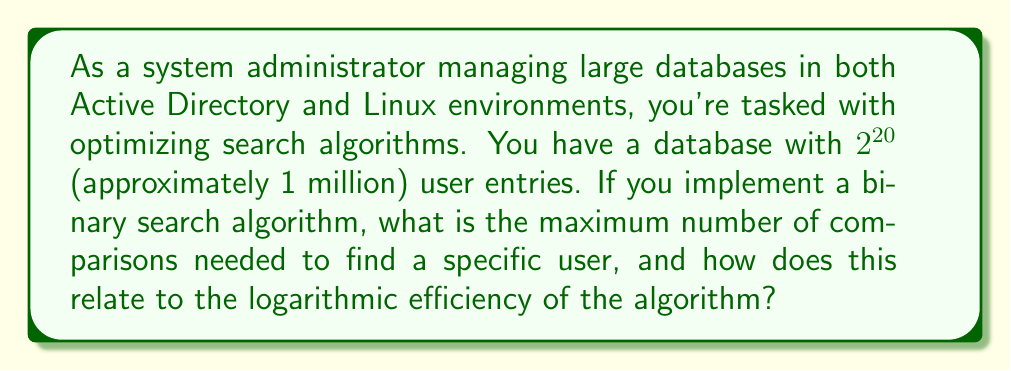Teach me how to tackle this problem. To solve this problem, we need to understand the efficiency of binary search algorithms and how they relate to logarithms.

1) Binary search works by repeatedly dividing the search interval in half. The maximum number of comparisons needed is related to how many times we can divide the total number of entries by 2 until we reach 1.

2) This is precisely what the logarithm base 2 represents. The formula for the maximum number of comparisons in a binary search is:

   $$\lfloor \log_2(n) \rfloor + 1$$

   Where $n$ is the number of entries, and $\lfloor \rfloor$ represents the floor function.

3) In this case, $n = 2^{20}$

4) Applying the formula:

   $$\lfloor \log_2(2^{20}) \rfloor + 1$$

5) Using the logarithm property $\log_a(a^x) = x$:

   $$\lfloor 20 \rfloor + 1 = 20 + 1 = 21$$

6) This logarithmic efficiency demonstrates why binary search is so powerful for large datasets. While the database size is about 1 million entries, we only need a maximum of 21 comparisons.

7) To put this in perspective, a linear search would require up to 1 million comparisons in the worst case.

8) The efficiency gain becomes even more pronounced as the database grows. For example, doubling the database size to $2^{21}$ would only increase the maximum comparisons to 22.
Answer: The maximum number of comparisons needed is 21. This demonstrates the logarithmic efficiency of binary search, as it can locate any entry in a database of about 1 million items with at most 21 comparisons. 